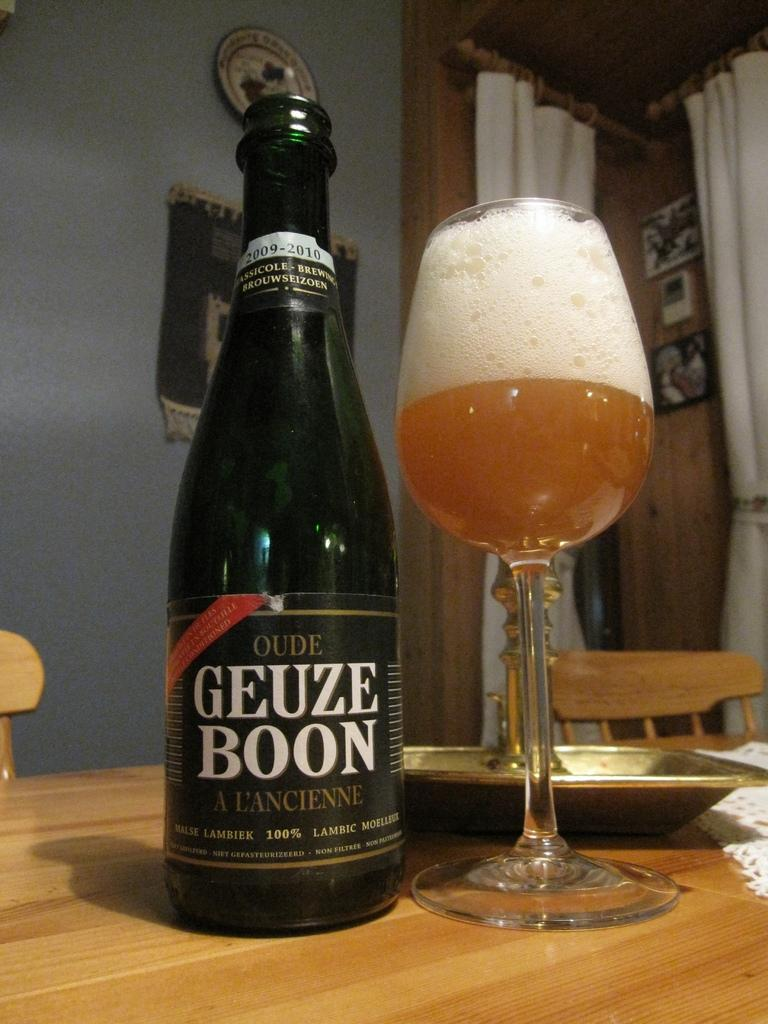<image>
Provide a brief description of the given image. A bottle of Oude Geuze Boon is sitting next to a full glass on a table. 